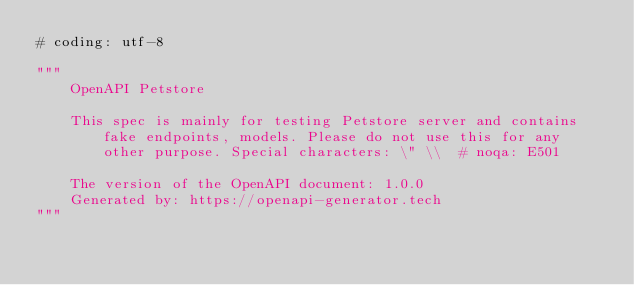<code> <loc_0><loc_0><loc_500><loc_500><_Python_># coding: utf-8

"""
    OpenAPI Petstore

    This spec is mainly for testing Petstore server and contains fake endpoints, models. Please do not use this for any other purpose. Special characters: \" \\  # noqa: E501

    The version of the OpenAPI document: 1.0.0
    Generated by: https://openapi-generator.tech
"""

</code> 